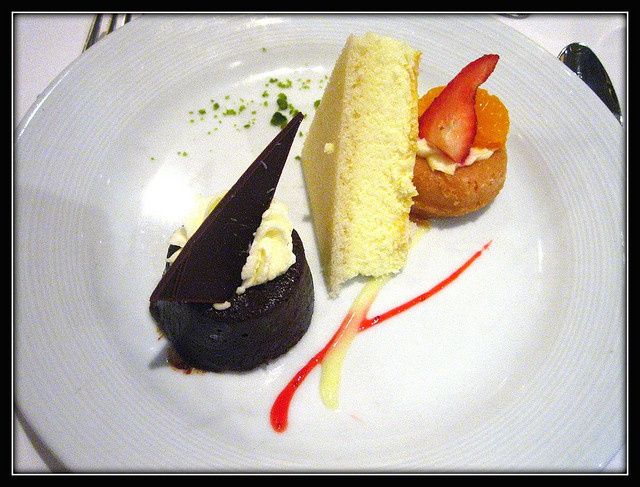Describe the objects in this image and their specific colors. I can see cake in black, khaki, beige, and tan tones, cake in black, navy, khaki, and beige tones, cake in black, red, orange, and brown tones, donut in black, red, orange, and brown tones, and spoon in black, navy, gray, and white tones in this image. 